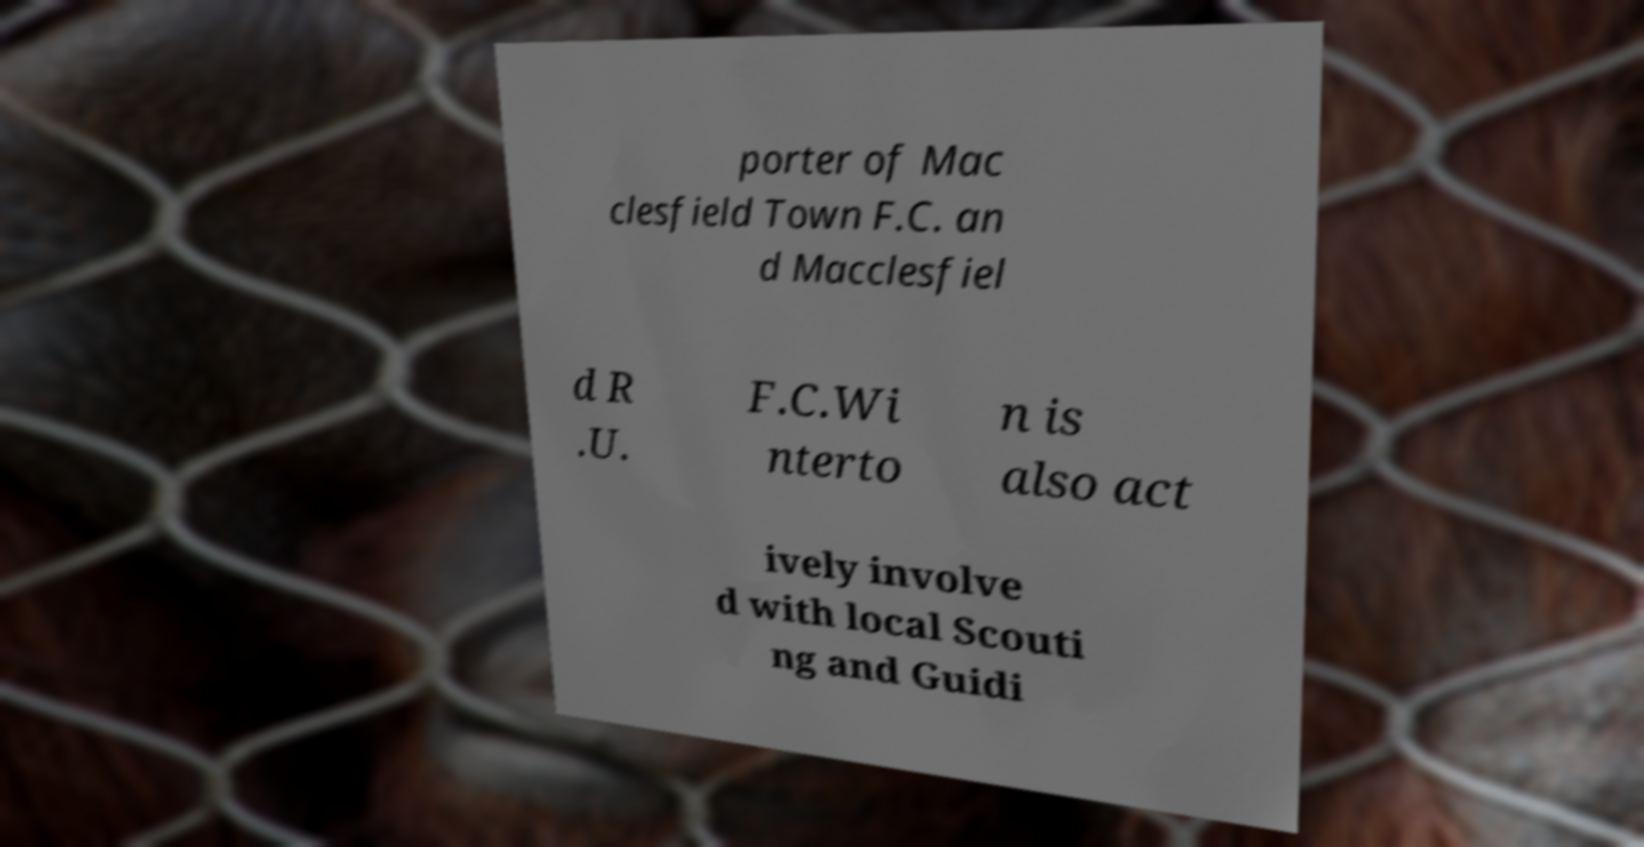I need the written content from this picture converted into text. Can you do that? porter of Mac clesfield Town F.C. an d Macclesfiel d R .U. F.C.Wi nterto n is also act ively involve d with local Scouti ng and Guidi 